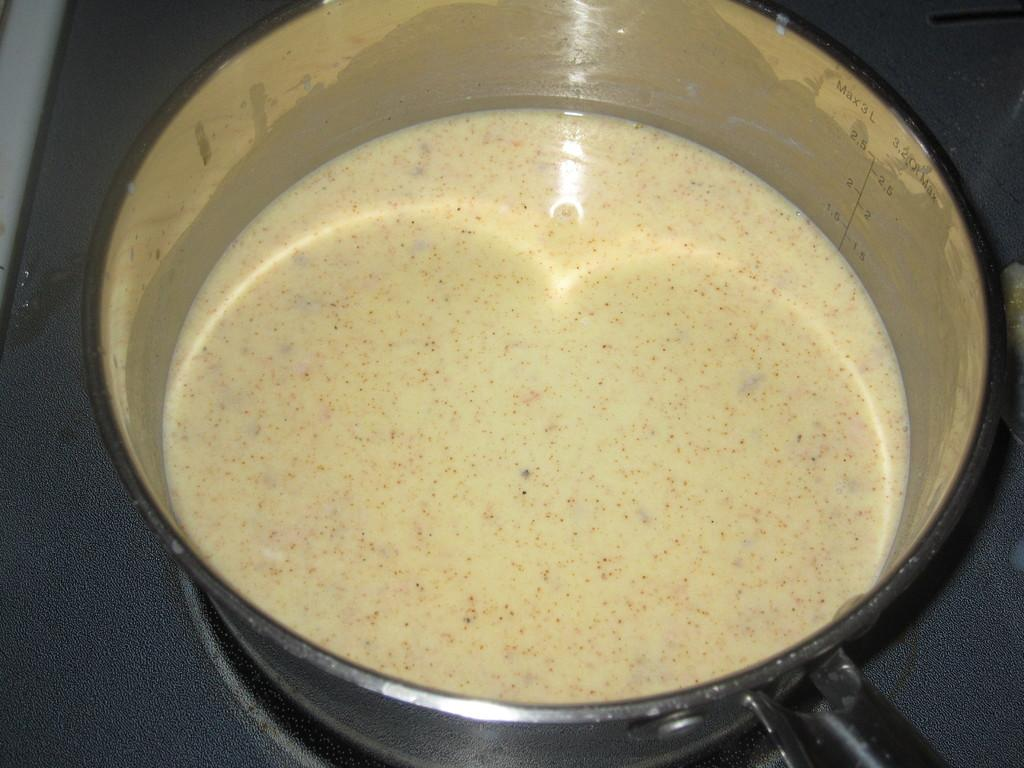What is in the bowl that is visible in the image? There is a food item in the bowl. Where is the bowl located in the image? The bowl is on a platform. What type of iron can be seen being used to balance the bowl in the image? There is no iron present in the image, nor is there any indication of the bowl being balanced. 